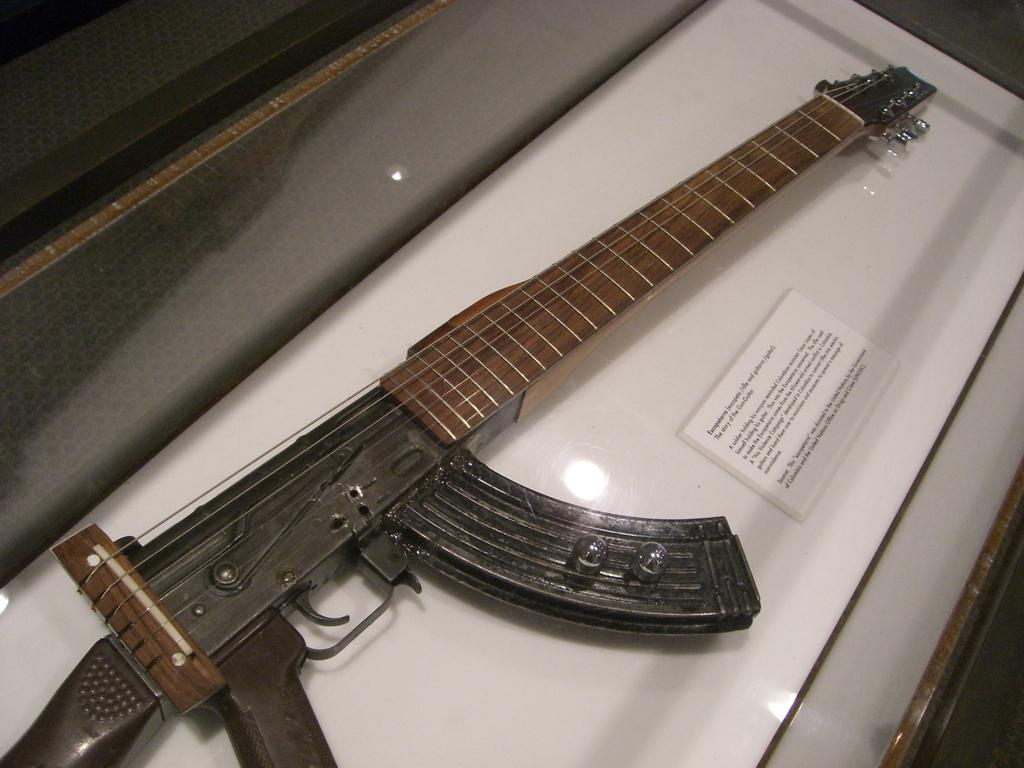What musical instrument is present in the image? There is a guitar in the image. How does the guitar appear in the image? The guitar resembles a gun in the image. What other object is present in the image besides the guitar? There is a card in the image. Can you describe the card in the image? The card has some script on it. What type of screw can be seen on the guitar in the image? There is no screw visible on the guitar in the image. Can you describe the tail of the guitar in the image? There is no tail present on the guitar in the image. 